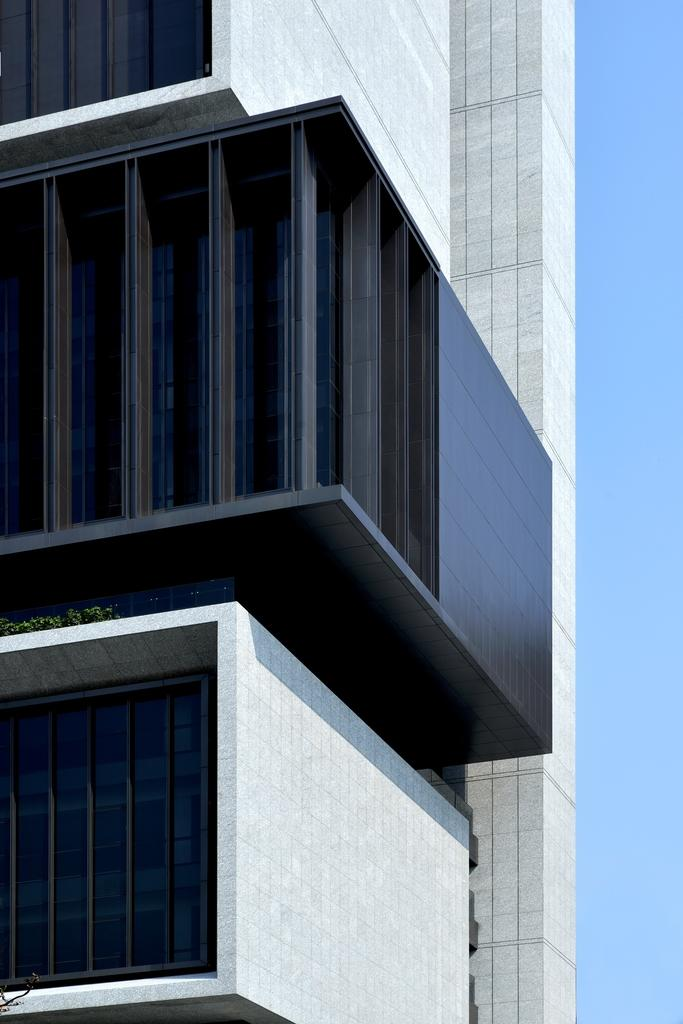What type of structure is present in the image? There is a building in the image. What other elements can be seen in the image besides the building? There are plants visible in the image. What is visible in the background of the image? The sky is visible in the background of the image. What is the color of the sky in the image? The color of the sky is blue. Can you see a hose being used to water the plants in the image? There is no hose visible in the image. Are there any people in the image engaging in a fight? There are no people or fights present in the image. What type of furniture can be seen in the image? There is no furniture present in the image. 